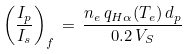Convert formula to latex. <formula><loc_0><loc_0><loc_500><loc_500>\left ( \frac { I _ { p } } { I _ { s } } \right ) _ { f } \, = \, \frac { n _ { e } \, q _ { H \alpha } ( T _ { e } ) \, d _ { p } } { 0 . 2 \, V _ { S } }</formula> 